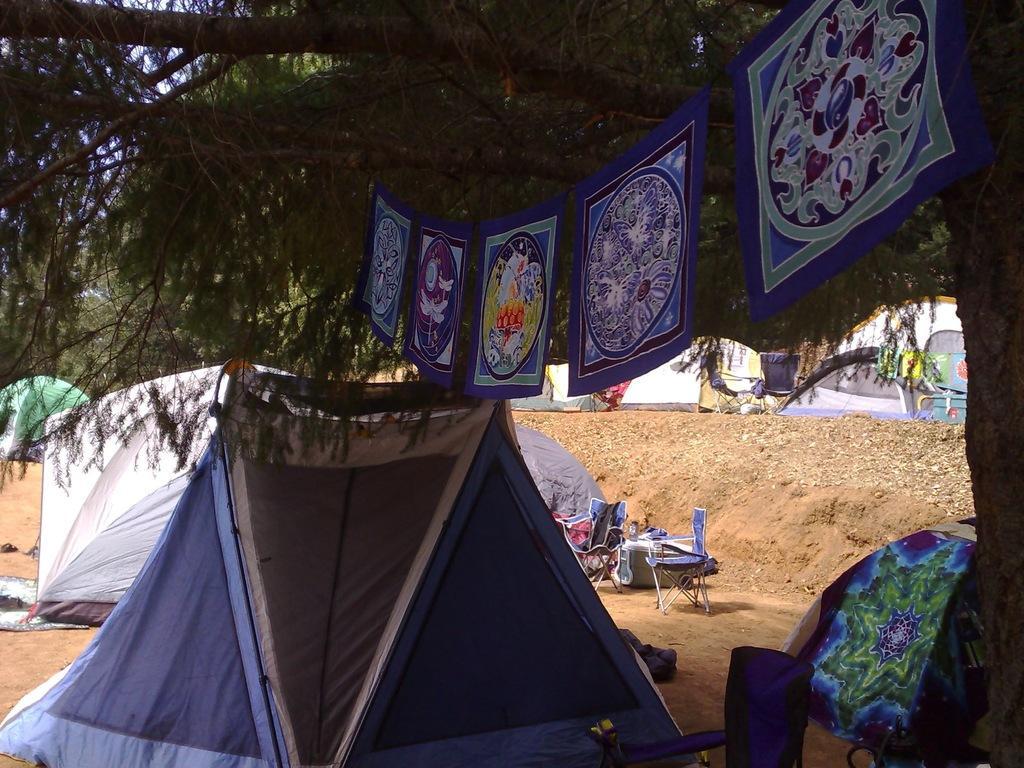Could you give a brief overview of what you see in this image? In the image there are many tents on the mud land, on the right side there is a tree with a hanger and some clothes hanging to it, in the middle there are some chairs on the land. 